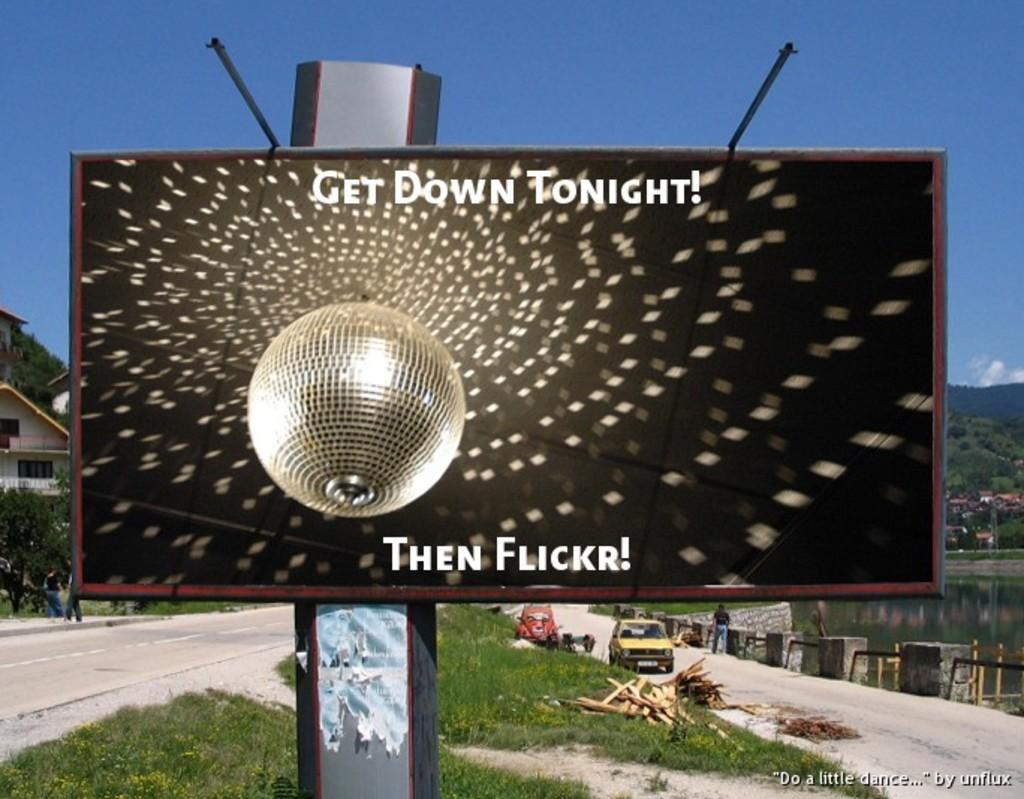Provide a one-sentence caption for the provided image. Get down tonight then flickr poster advertisement on a metal post. 